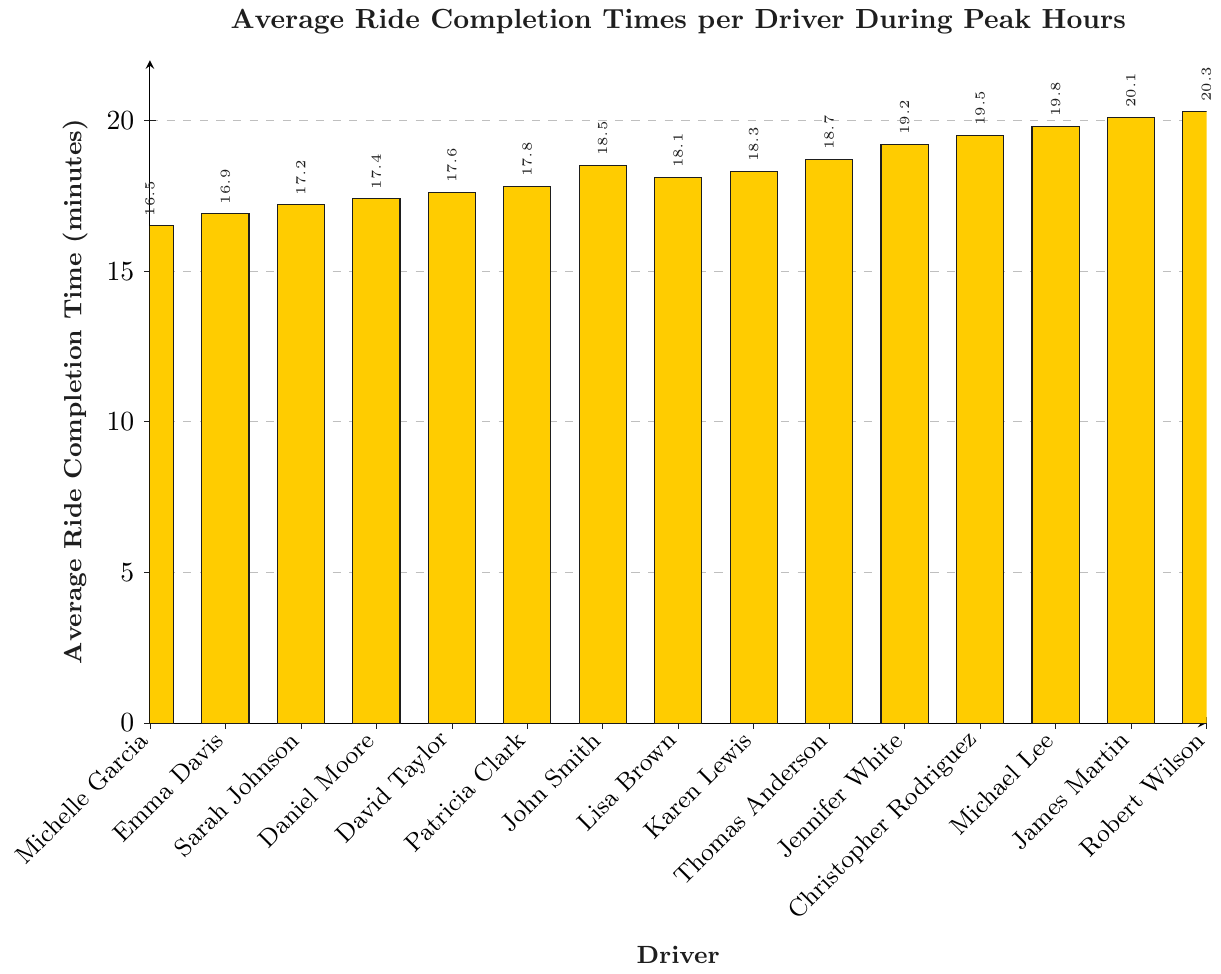What's the average ride completion time for drivers with names starting with 'J'? Identify drivers named 'John Smith', 'Jennifer White', 'James Martin', calculate average: (18.5 + 19.2 + 20.1)/3 ≈ 19.27 minutes
Answer: 19.27 Which driver has the shortest average ride completion time? Compare all drivers' average times and find the minimum value which is Michelle Garcia with 16.5 minutes
Answer: Michelle Garcia What's the difference in average ride completion time between the fastest and the slowest drivers? Fastest is Michelle Garcia with 16.5 minutes, slowest is Robert Wilson with 20.3 minutes. Difference: 20.3 - 16.5 = 3.8 minutes
Answer: 3.8 How many drivers have an average ride completion time of less than 18 minutes? Count the bars with values below 18: Michelle Garcia, Emma Davis, Sarah Johnson, Daniel Moore, David Taylor, Patricia Clark. Total = 6
Answer: 6 What's the median average ride completion time among all drivers? Sort times: [16.5, 16.9, 17.2, 17.4, 17.6, 17.8, 18.1, 18.3, 18.5, 18.7, 19.2, 19.5, 19.8, 20.1, 20.3], find middle value = 18.3 (Karen Lewis)
Answer: 18.3 Which drivers have average ride completion times between 17 minutes and 18 minutes? Identify and list drivers in the range 17 to 18: Sarah Johnson, Daniel Moore, David Taylor, Patricia Clark
Answer: Sarah Johnson, Daniel Moore, David Taylor, Patricia Clark What's the total average ride completion time for all drivers combined? Sum all the given average times: 281.5 minutes
Answer: 281.5 Which driver has the average ride completion time closest to 20 minutes? Compare values around 20: Michael Lee (19.8), James Martin (20.1), Robert Wilson (20.3); James Martin is closest
Answer: James Martin Is the average ride completion time higher for drivers whose names start with 'M' or 'D'? Calculate average for 'M' drivers: [Michael Lee, Michelle Garcia] = (19.8 + 16.5)/2 = 18.15, and 'D' drivers: [Daniel Moore, David Taylor] = (17.4 + 17.6)/2 = 17.5. Compare 18.15 > 17.5
Answer: M drivers Assuming efficiency is inversely proportional to completion time, who would be ranked second after Michelle Garcia? Efficient drivers with low times: Michelle Garcia (16.5), Emma Davis (16.9); second-highest efficiency is Emma Davis
Answer: Emma Davis 